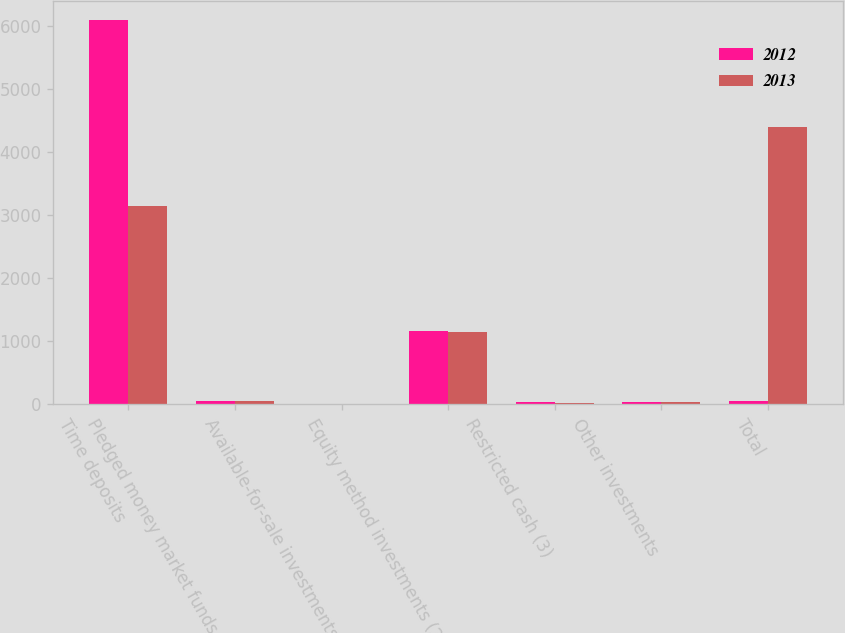<chart> <loc_0><loc_0><loc_500><loc_500><stacked_bar_chart><ecel><fcel>Time deposits<fcel>Pledged money market funds (1)<fcel>Available-for-sale investments<fcel>Equity method investments (2)<fcel>Restricted cash (3)<fcel>Other investments<fcel>Total<nl><fcel>2012<fcel>6090<fcel>46<fcel>8<fcel>1164<fcel>33<fcel>33<fcel>46<nl><fcel>2013<fcel>3135<fcel>56<fcel>9<fcel>1137<fcel>25<fcel>35<fcel>4397<nl></chart> 